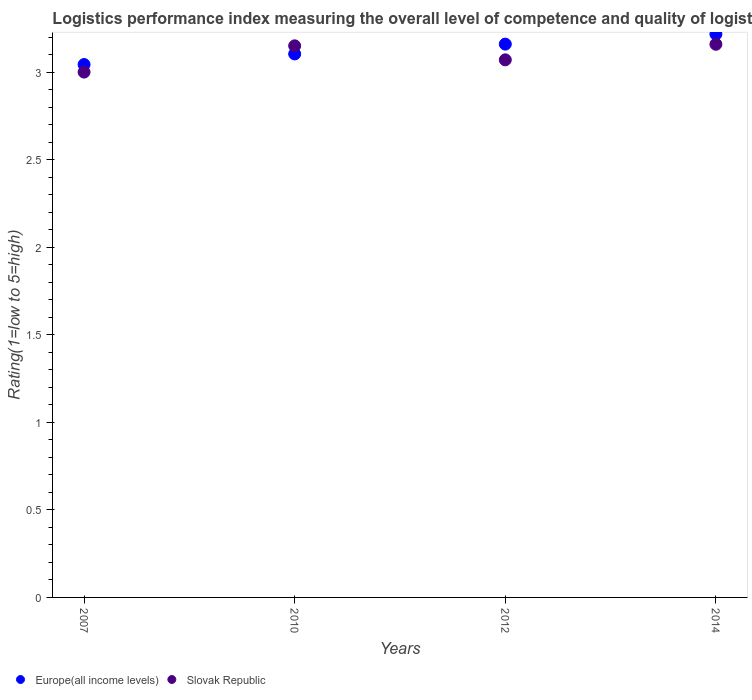How many different coloured dotlines are there?
Provide a short and direct response. 2. Is the number of dotlines equal to the number of legend labels?
Offer a very short reply. Yes. What is the Logistic performance index in Slovak Republic in 2012?
Make the answer very short. 3.07. Across all years, what is the maximum Logistic performance index in Europe(all income levels)?
Your response must be concise. 3.22. Across all years, what is the minimum Logistic performance index in Europe(all income levels)?
Provide a short and direct response. 3.04. In which year was the Logistic performance index in Europe(all income levels) maximum?
Make the answer very short. 2014. What is the total Logistic performance index in Europe(all income levels) in the graph?
Keep it short and to the point. 12.52. What is the difference between the Logistic performance index in Europe(all income levels) in 2007 and that in 2014?
Keep it short and to the point. -0.17. What is the difference between the Logistic performance index in Slovak Republic in 2010 and the Logistic performance index in Europe(all income levels) in 2012?
Your response must be concise. -0.01. What is the average Logistic performance index in Slovak Republic per year?
Offer a very short reply. 3.09. In the year 2010, what is the difference between the Logistic performance index in Europe(all income levels) and Logistic performance index in Slovak Republic?
Provide a short and direct response. -0.05. What is the ratio of the Logistic performance index in Slovak Republic in 2012 to that in 2014?
Your response must be concise. 0.97. Is the Logistic performance index in Europe(all income levels) in 2007 less than that in 2014?
Offer a very short reply. Yes. Is the difference between the Logistic performance index in Europe(all income levels) in 2012 and 2014 greater than the difference between the Logistic performance index in Slovak Republic in 2012 and 2014?
Offer a terse response. Yes. What is the difference between the highest and the second highest Logistic performance index in Europe(all income levels)?
Give a very brief answer. 0.06. What is the difference between the highest and the lowest Logistic performance index in Slovak Republic?
Make the answer very short. 0.16. In how many years, is the Logistic performance index in Europe(all income levels) greater than the average Logistic performance index in Europe(all income levels) taken over all years?
Make the answer very short. 2. Is the sum of the Logistic performance index in Slovak Republic in 2010 and 2014 greater than the maximum Logistic performance index in Europe(all income levels) across all years?
Provide a short and direct response. Yes. Is the Logistic performance index in Slovak Republic strictly greater than the Logistic performance index in Europe(all income levels) over the years?
Your answer should be very brief. No. Is the Logistic performance index in Europe(all income levels) strictly less than the Logistic performance index in Slovak Republic over the years?
Your answer should be compact. No. How many years are there in the graph?
Offer a very short reply. 4. What is the difference between two consecutive major ticks on the Y-axis?
Keep it short and to the point. 0.5. Does the graph contain any zero values?
Keep it short and to the point. No. Does the graph contain grids?
Ensure brevity in your answer.  No. How are the legend labels stacked?
Provide a short and direct response. Horizontal. What is the title of the graph?
Your response must be concise. Logistics performance index measuring the overall level of competence and quality of logistics services. Does "El Salvador" appear as one of the legend labels in the graph?
Your answer should be very brief. No. What is the label or title of the Y-axis?
Give a very brief answer. Rating(1=low to 5=high). What is the Rating(1=low to 5=high) in Europe(all income levels) in 2007?
Your response must be concise. 3.04. What is the Rating(1=low to 5=high) in Europe(all income levels) in 2010?
Provide a succinct answer. 3.1. What is the Rating(1=low to 5=high) of Slovak Republic in 2010?
Make the answer very short. 3.15. What is the Rating(1=low to 5=high) of Europe(all income levels) in 2012?
Provide a succinct answer. 3.16. What is the Rating(1=low to 5=high) in Slovak Republic in 2012?
Your answer should be compact. 3.07. What is the Rating(1=low to 5=high) in Europe(all income levels) in 2014?
Your response must be concise. 3.22. What is the Rating(1=low to 5=high) in Slovak Republic in 2014?
Give a very brief answer. 3.16. Across all years, what is the maximum Rating(1=low to 5=high) of Europe(all income levels)?
Offer a very short reply. 3.22. Across all years, what is the maximum Rating(1=low to 5=high) of Slovak Republic?
Your response must be concise. 3.16. Across all years, what is the minimum Rating(1=low to 5=high) in Europe(all income levels)?
Your answer should be compact. 3.04. What is the total Rating(1=low to 5=high) in Europe(all income levels) in the graph?
Provide a succinct answer. 12.52. What is the total Rating(1=low to 5=high) in Slovak Republic in the graph?
Provide a succinct answer. 12.38. What is the difference between the Rating(1=low to 5=high) of Europe(all income levels) in 2007 and that in 2010?
Offer a terse response. -0.06. What is the difference between the Rating(1=low to 5=high) of Europe(all income levels) in 2007 and that in 2012?
Provide a succinct answer. -0.12. What is the difference between the Rating(1=low to 5=high) of Slovak Republic in 2007 and that in 2012?
Offer a very short reply. -0.07. What is the difference between the Rating(1=low to 5=high) of Europe(all income levels) in 2007 and that in 2014?
Provide a succinct answer. -0.17. What is the difference between the Rating(1=low to 5=high) of Slovak Republic in 2007 and that in 2014?
Provide a succinct answer. -0.16. What is the difference between the Rating(1=low to 5=high) in Europe(all income levels) in 2010 and that in 2012?
Offer a very short reply. -0.06. What is the difference between the Rating(1=low to 5=high) of Slovak Republic in 2010 and that in 2012?
Your answer should be very brief. 0.08. What is the difference between the Rating(1=low to 5=high) in Europe(all income levels) in 2010 and that in 2014?
Your response must be concise. -0.11. What is the difference between the Rating(1=low to 5=high) of Slovak Republic in 2010 and that in 2014?
Provide a succinct answer. -0.01. What is the difference between the Rating(1=low to 5=high) of Europe(all income levels) in 2012 and that in 2014?
Your answer should be very brief. -0.06. What is the difference between the Rating(1=low to 5=high) of Slovak Republic in 2012 and that in 2014?
Ensure brevity in your answer.  -0.09. What is the difference between the Rating(1=low to 5=high) of Europe(all income levels) in 2007 and the Rating(1=low to 5=high) of Slovak Republic in 2010?
Make the answer very short. -0.11. What is the difference between the Rating(1=low to 5=high) in Europe(all income levels) in 2007 and the Rating(1=low to 5=high) in Slovak Republic in 2012?
Offer a very short reply. -0.03. What is the difference between the Rating(1=low to 5=high) in Europe(all income levels) in 2007 and the Rating(1=low to 5=high) in Slovak Republic in 2014?
Make the answer very short. -0.12. What is the difference between the Rating(1=low to 5=high) of Europe(all income levels) in 2010 and the Rating(1=low to 5=high) of Slovak Republic in 2012?
Provide a succinct answer. 0.03. What is the difference between the Rating(1=low to 5=high) in Europe(all income levels) in 2010 and the Rating(1=low to 5=high) in Slovak Republic in 2014?
Keep it short and to the point. -0.06. What is the difference between the Rating(1=low to 5=high) in Europe(all income levels) in 2012 and the Rating(1=low to 5=high) in Slovak Republic in 2014?
Provide a succinct answer. 0. What is the average Rating(1=low to 5=high) of Europe(all income levels) per year?
Provide a short and direct response. 3.13. What is the average Rating(1=low to 5=high) in Slovak Republic per year?
Offer a very short reply. 3.09. In the year 2007, what is the difference between the Rating(1=low to 5=high) of Europe(all income levels) and Rating(1=low to 5=high) of Slovak Republic?
Your answer should be very brief. 0.04. In the year 2010, what is the difference between the Rating(1=low to 5=high) in Europe(all income levels) and Rating(1=low to 5=high) in Slovak Republic?
Offer a terse response. -0.05. In the year 2012, what is the difference between the Rating(1=low to 5=high) in Europe(all income levels) and Rating(1=low to 5=high) in Slovak Republic?
Keep it short and to the point. 0.09. In the year 2014, what is the difference between the Rating(1=low to 5=high) in Europe(all income levels) and Rating(1=low to 5=high) in Slovak Republic?
Give a very brief answer. 0.06. What is the ratio of the Rating(1=low to 5=high) of Europe(all income levels) in 2007 to that in 2010?
Give a very brief answer. 0.98. What is the ratio of the Rating(1=low to 5=high) of Europe(all income levels) in 2007 to that in 2012?
Give a very brief answer. 0.96. What is the ratio of the Rating(1=low to 5=high) of Slovak Republic in 2007 to that in 2012?
Provide a succinct answer. 0.98. What is the ratio of the Rating(1=low to 5=high) in Europe(all income levels) in 2007 to that in 2014?
Ensure brevity in your answer.  0.95. What is the ratio of the Rating(1=low to 5=high) of Slovak Republic in 2007 to that in 2014?
Make the answer very short. 0.95. What is the ratio of the Rating(1=low to 5=high) of Europe(all income levels) in 2010 to that in 2012?
Your answer should be very brief. 0.98. What is the ratio of the Rating(1=low to 5=high) of Slovak Republic in 2010 to that in 2012?
Offer a very short reply. 1.03. What is the ratio of the Rating(1=low to 5=high) of Europe(all income levels) in 2010 to that in 2014?
Provide a short and direct response. 0.96. What is the ratio of the Rating(1=low to 5=high) of Europe(all income levels) in 2012 to that in 2014?
Make the answer very short. 0.98. What is the ratio of the Rating(1=low to 5=high) of Slovak Republic in 2012 to that in 2014?
Your answer should be compact. 0.97. What is the difference between the highest and the second highest Rating(1=low to 5=high) in Europe(all income levels)?
Offer a very short reply. 0.06. What is the difference between the highest and the second highest Rating(1=low to 5=high) in Slovak Republic?
Ensure brevity in your answer.  0.01. What is the difference between the highest and the lowest Rating(1=low to 5=high) of Europe(all income levels)?
Keep it short and to the point. 0.17. What is the difference between the highest and the lowest Rating(1=low to 5=high) in Slovak Republic?
Make the answer very short. 0.16. 